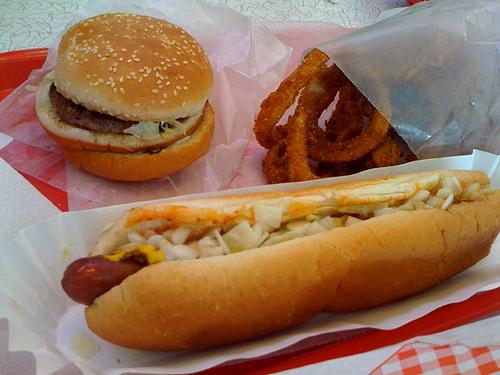Where could you get this food?

Choices:
A) fruit vendor
B) taco truck
C) starbucks
D) burger joint burger joint 